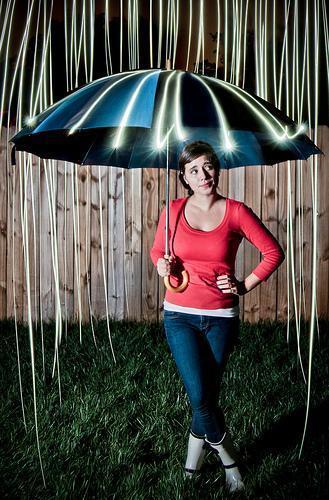How many people are pictured?
Give a very brief answer. 1. 